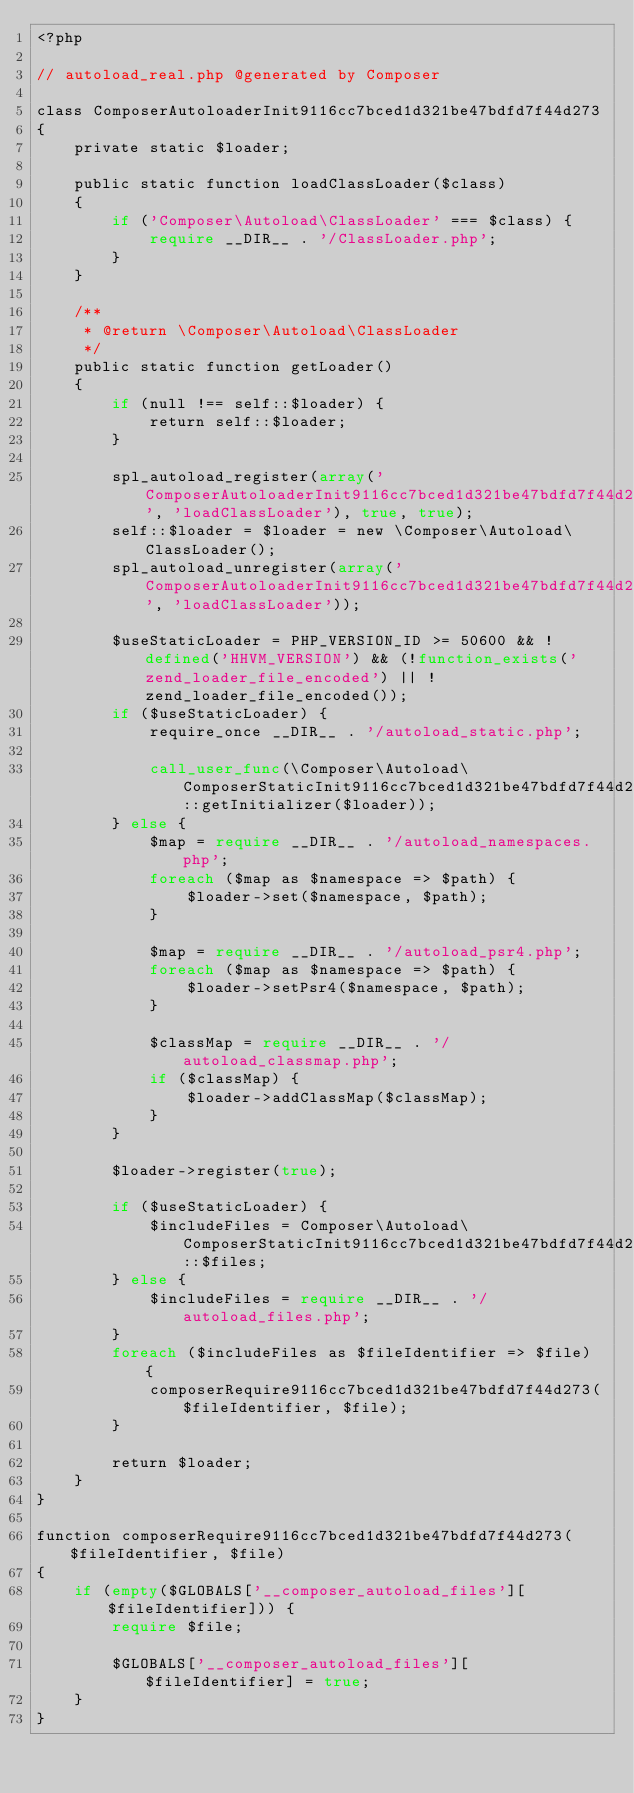Convert code to text. <code><loc_0><loc_0><loc_500><loc_500><_PHP_><?php

// autoload_real.php @generated by Composer

class ComposerAutoloaderInit9116cc7bced1d321be47bdfd7f44d273
{
    private static $loader;

    public static function loadClassLoader($class)
    {
        if ('Composer\Autoload\ClassLoader' === $class) {
            require __DIR__ . '/ClassLoader.php';
        }
    }

    /**
     * @return \Composer\Autoload\ClassLoader
     */
    public static function getLoader()
    {
        if (null !== self::$loader) {
            return self::$loader;
        }

        spl_autoload_register(array('ComposerAutoloaderInit9116cc7bced1d321be47bdfd7f44d273', 'loadClassLoader'), true, true);
        self::$loader = $loader = new \Composer\Autoload\ClassLoader();
        spl_autoload_unregister(array('ComposerAutoloaderInit9116cc7bced1d321be47bdfd7f44d273', 'loadClassLoader'));

        $useStaticLoader = PHP_VERSION_ID >= 50600 && !defined('HHVM_VERSION') && (!function_exists('zend_loader_file_encoded') || !zend_loader_file_encoded());
        if ($useStaticLoader) {
            require_once __DIR__ . '/autoload_static.php';

            call_user_func(\Composer\Autoload\ComposerStaticInit9116cc7bced1d321be47bdfd7f44d273::getInitializer($loader));
        } else {
            $map = require __DIR__ . '/autoload_namespaces.php';
            foreach ($map as $namespace => $path) {
                $loader->set($namespace, $path);
            }

            $map = require __DIR__ . '/autoload_psr4.php';
            foreach ($map as $namespace => $path) {
                $loader->setPsr4($namespace, $path);
            }

            $classMap = require __DIR__ . '/autoload_classmap.php';
            if ($classMap) {
                $loader->addClassMap($classMap);
            }
        }

        $loader->register(true);

        if ($useStaticLoader) {
            $includeFiles = Composer\Autoload\ComposerStaticInit9116cc7bced1d321be47bdfd7f44d273::$files;
        } else {
            $includeFiles = require __DIR__ . '/autoload_files.php';
        }
        foreach ($includeFiles as $fileIdentifier => $file) {
            composerRequire9116cc7bced1d321be47bdfd7f44d273($fileIdentifier, $file);
        }

        return $loader;
    }
}

function composerRequire9116cc7bced1d321be47bdfd7f44d273($fileIdentifier, $file)
{
    if (empty($GLOBALS['__composer_autoload_files'][$fileIdentifier])) {
        require $file;

        $GLOBALS['__composer_autoload_files'][$fileIdentifier] = true;
    }
}
</code> 